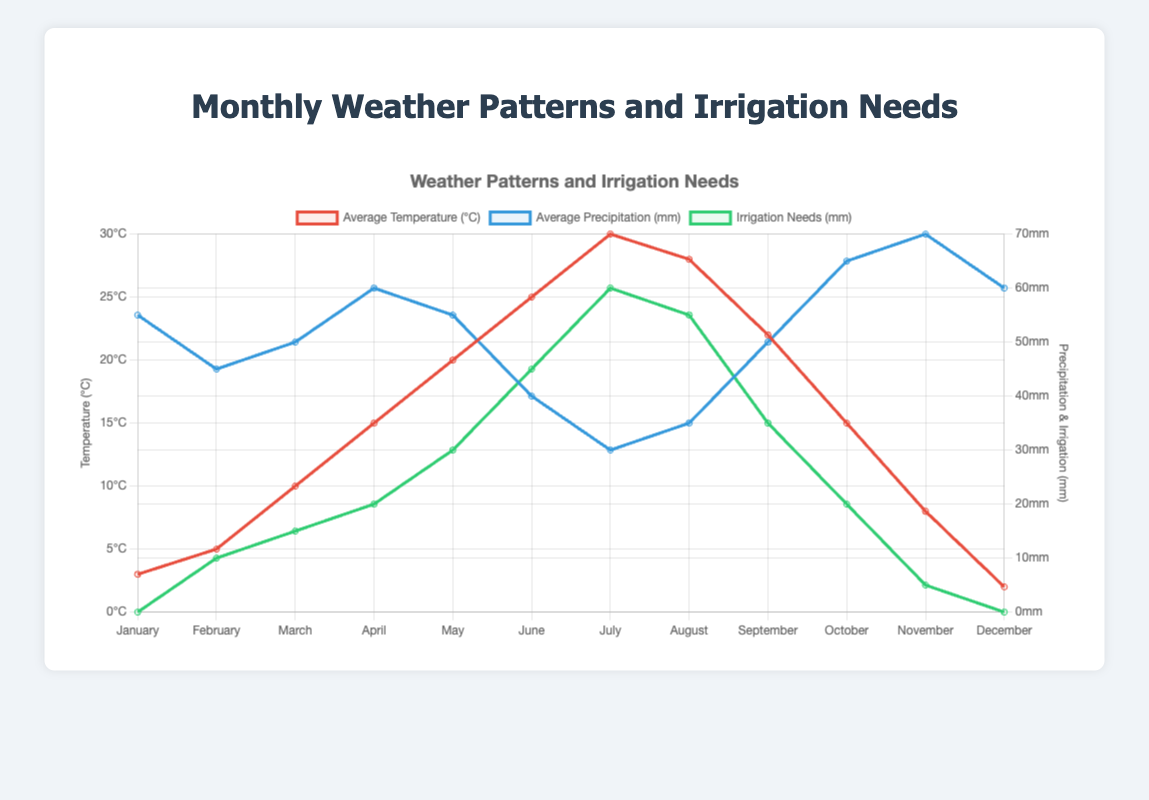What's the month with the highest average temperature? Look at the red line in the chart representing the average temperature. July peaks at 30°C, making it the highest temperature.
Answer: July What's the month with the lowest irrigation needs? Refer to the green line that shows irrigation needs. Both January and December have the lowest irrigation needs at 0 mm.
Answer: January and December What's the average precipitation from June to August? Sum the average precipitation for June, July, and August: 40 mm + 30 mm + 35 mm = 105 mm. Then, divide by 3 (the number of months) to get the average: 105 mm / 3 = 35 mm.
Answer: 35 mm In which month do average temperature and average precipitation intersect? Observe the red and blue lines in the chart. They intersect in April, where both have approximate values (temperature = 15°C, precipitation = 60 mm).
Answer: April Which month shows the greatest difference between average temperature and irrigation needs? Calculate the differences for each month:
- January: 3 - 0 = 3
- February: 5 - 10 = -5
- March: 10 - 15 = -5
- April: 15 - 20 = -5
- May: 20 - 30 = -10
- June: 25 - 45 = -20
- July: 30 - 60 = -30
- August: 28 - 55 = -27
- September: 22 - 35 = -13
- October: 15 - 20 = -5
- November: 8 - 5 = 3
- December: 2 - 0 = 2
The greatest absolute difference is -30 in July.
Answer: July How does the average precipitation in March compare to the irrigation needs in the same month? Look at the blue line for average precipitation and the green line for irrigation needs in March. The average precipitation is 50 mm, and the irrigation needs are 15 mm.
Answer: Higher What month has the highest need for irrigation, and what is the corresponding average temperature? The green line representing irrigation needs peaks in July at 60 mm. The corresponding average temperature for July is 30°C.
Answer: July and 30°C Is there a month when average precipitation is higher than 60 mm? Check the blue line throughout the months. October has the highest value above 60 mm with a peak at 65 mm, followed by November at 70 mm.
Answer: October and November How many months have an irrigation need greater than 30 mm? Look at the green line for irrigation needs. June, July, August, and September have irrigation needs greater than 30 mm. That's 4 months.
Answer: 4 months In which month is the average temperature exactly half of the monthly average temperature in July? The average temperature in July is 30°C. Half of that is 30 / 2 = 15°C. The red line shows that April has an average temperature of 15°C.
Answer: April 